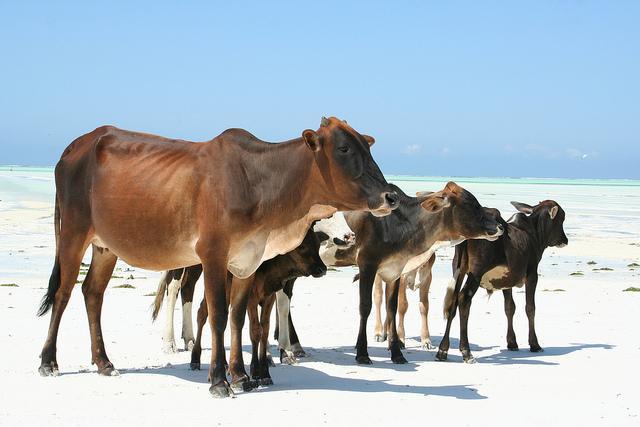How many cows are visible?
Give a very brief answer. 5. 